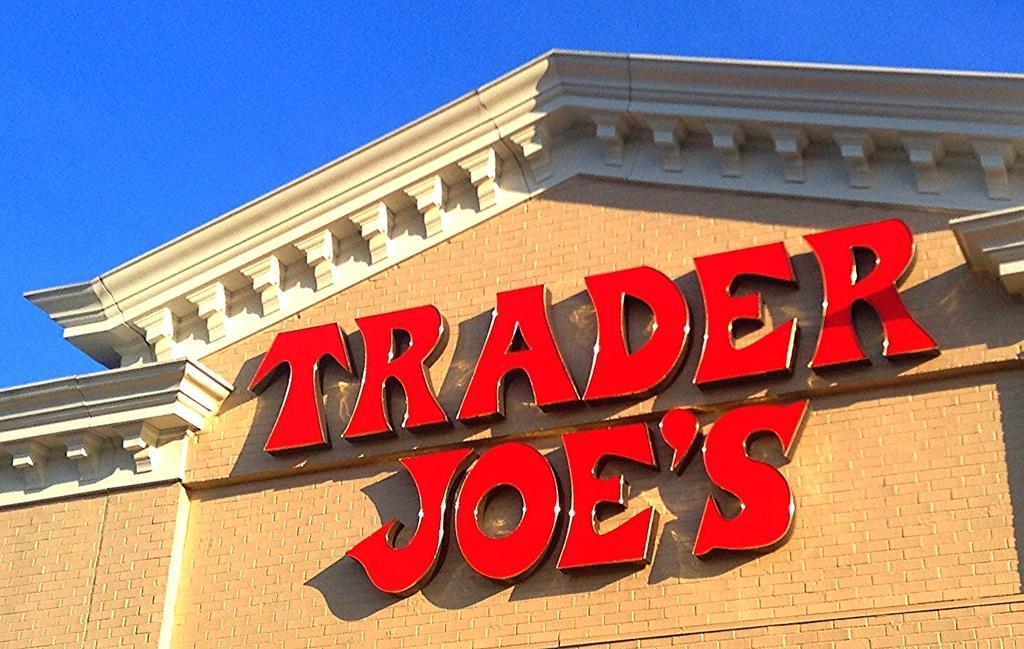Please provide a concise description of this image. In this image I can see a huge building which is brown and cream in color. I can see few red colored boards to the building. In the background I can see the sky. 